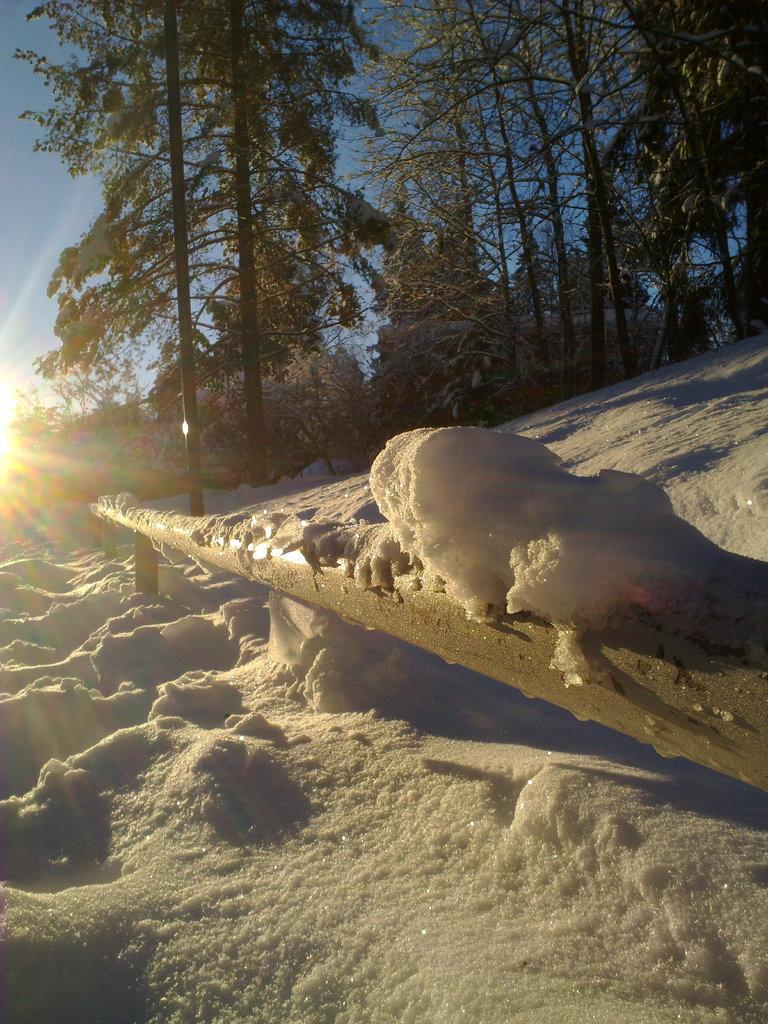What type of barrier can be seen in the image? There is a fence in the image. How is the ground depicted in the image? The ground is covered with snow. What can be seen in the distance in the image? There is a group of trees visible in the background. What celestial body is visible in the image? The sun is visible in the image. What is the condition of the sky in the image? The sky appears cloudy. What type of string is being used to decorate the trees in the image? There is no string or decoration visible on the trees in the image; they are simply a group of trees in the background. What type of glass object can be seen on the ground in the image? There is no glass object present on the ground in the image; the ground is covered with snow. 